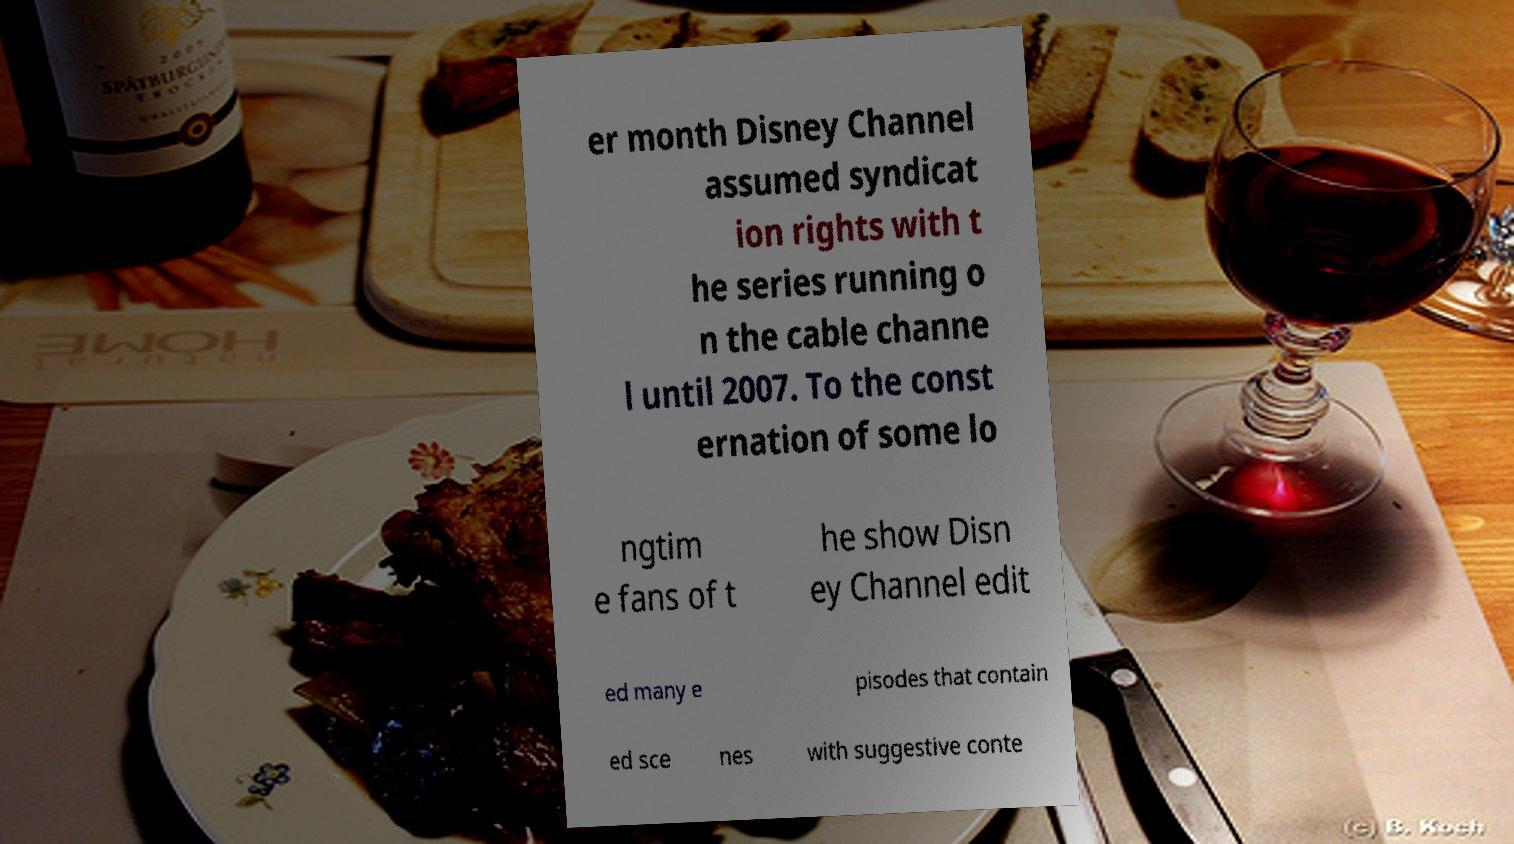Could you extract and type out the text from this image? er month Disney Channel assumed syndicat ion rights with t he series running o n the cable channe l until 2007. To the const ernation of some lo ngtim e fans of t he show Disn ey Channel edit ed many e pisodes that contain ed sce nes with suggestive conte 